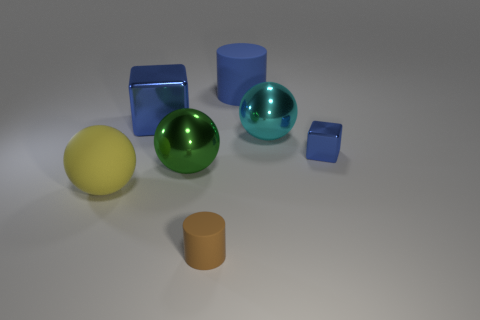Subtract all blue blocks. How many were subtracted if there are1blue blocks left? 1 Subtract all big metal balls. How many balls are left? 1 Subtract all green balls. How many balls are left? 2 Subtract all spheres. How many objects are left? 4 Subtract 1 cubes. How many cubes are left? 1 Subtract all green balls. Subtract all blue blocks. How many balls are left? 2 Subtract all blue spheres. How many gray cubes are left? 0 Subtract all green shiny cylinders. Subtract all big cyan shiny balls. How many objects are left? 6 Add 2 blue matte things. How many blue matte things are left? 3 Add 5 small cyan metallic cylinders. How many small cyan metallic cylinders exist? 5 